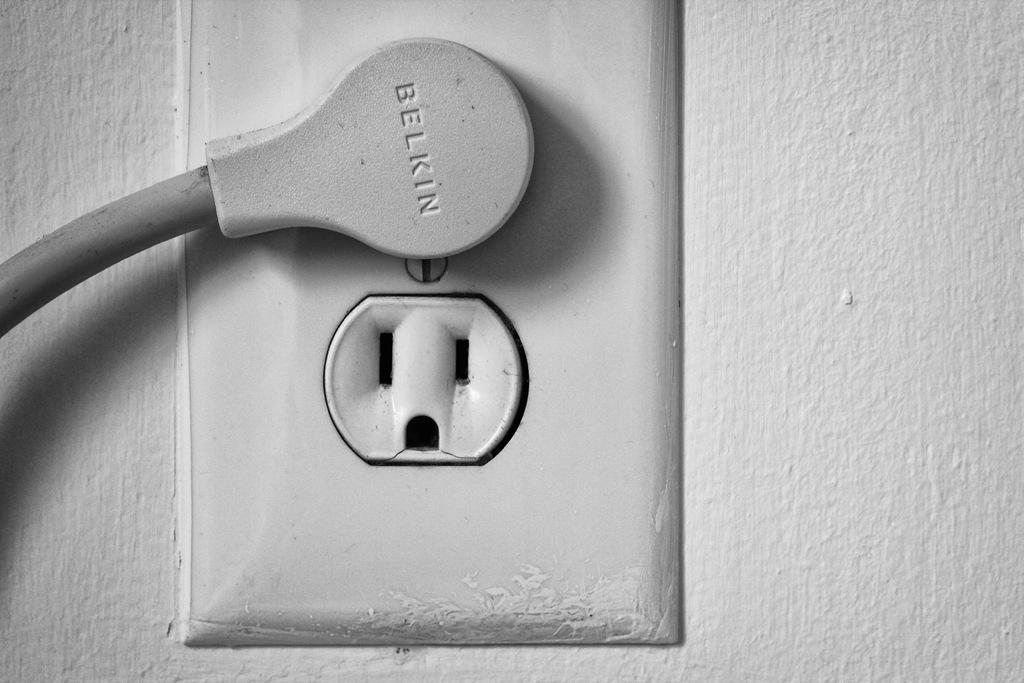Who manufactured the plug?
Offer a very short reply. Belkin. 